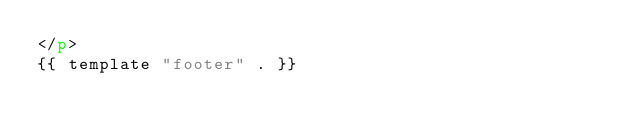Convert code to text. <code><loc_0><loc_0><loc_500><loc_500><_HTML_></p>
{{ template "footer" . }}

</code> 